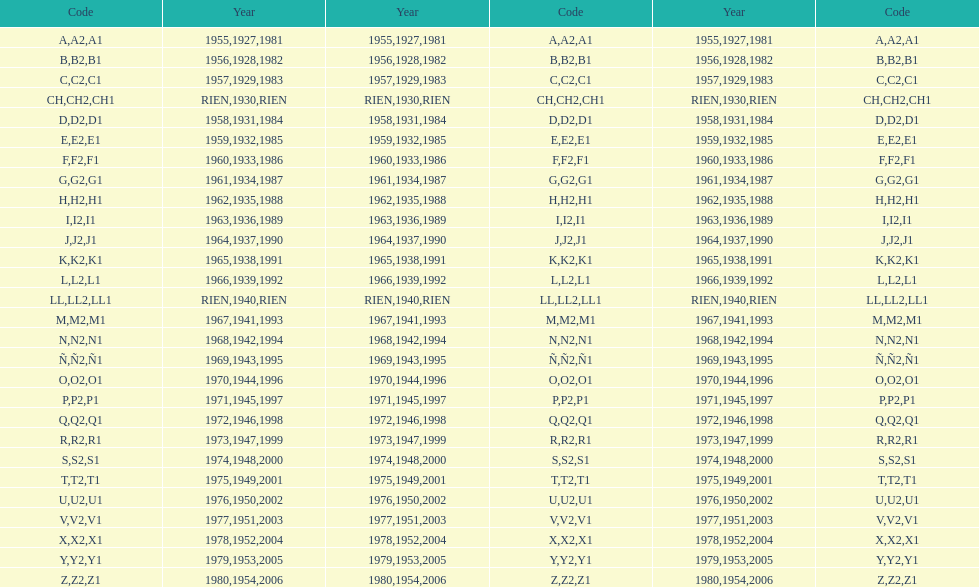How many various codes were employed from 1953 to 1958? 6. 